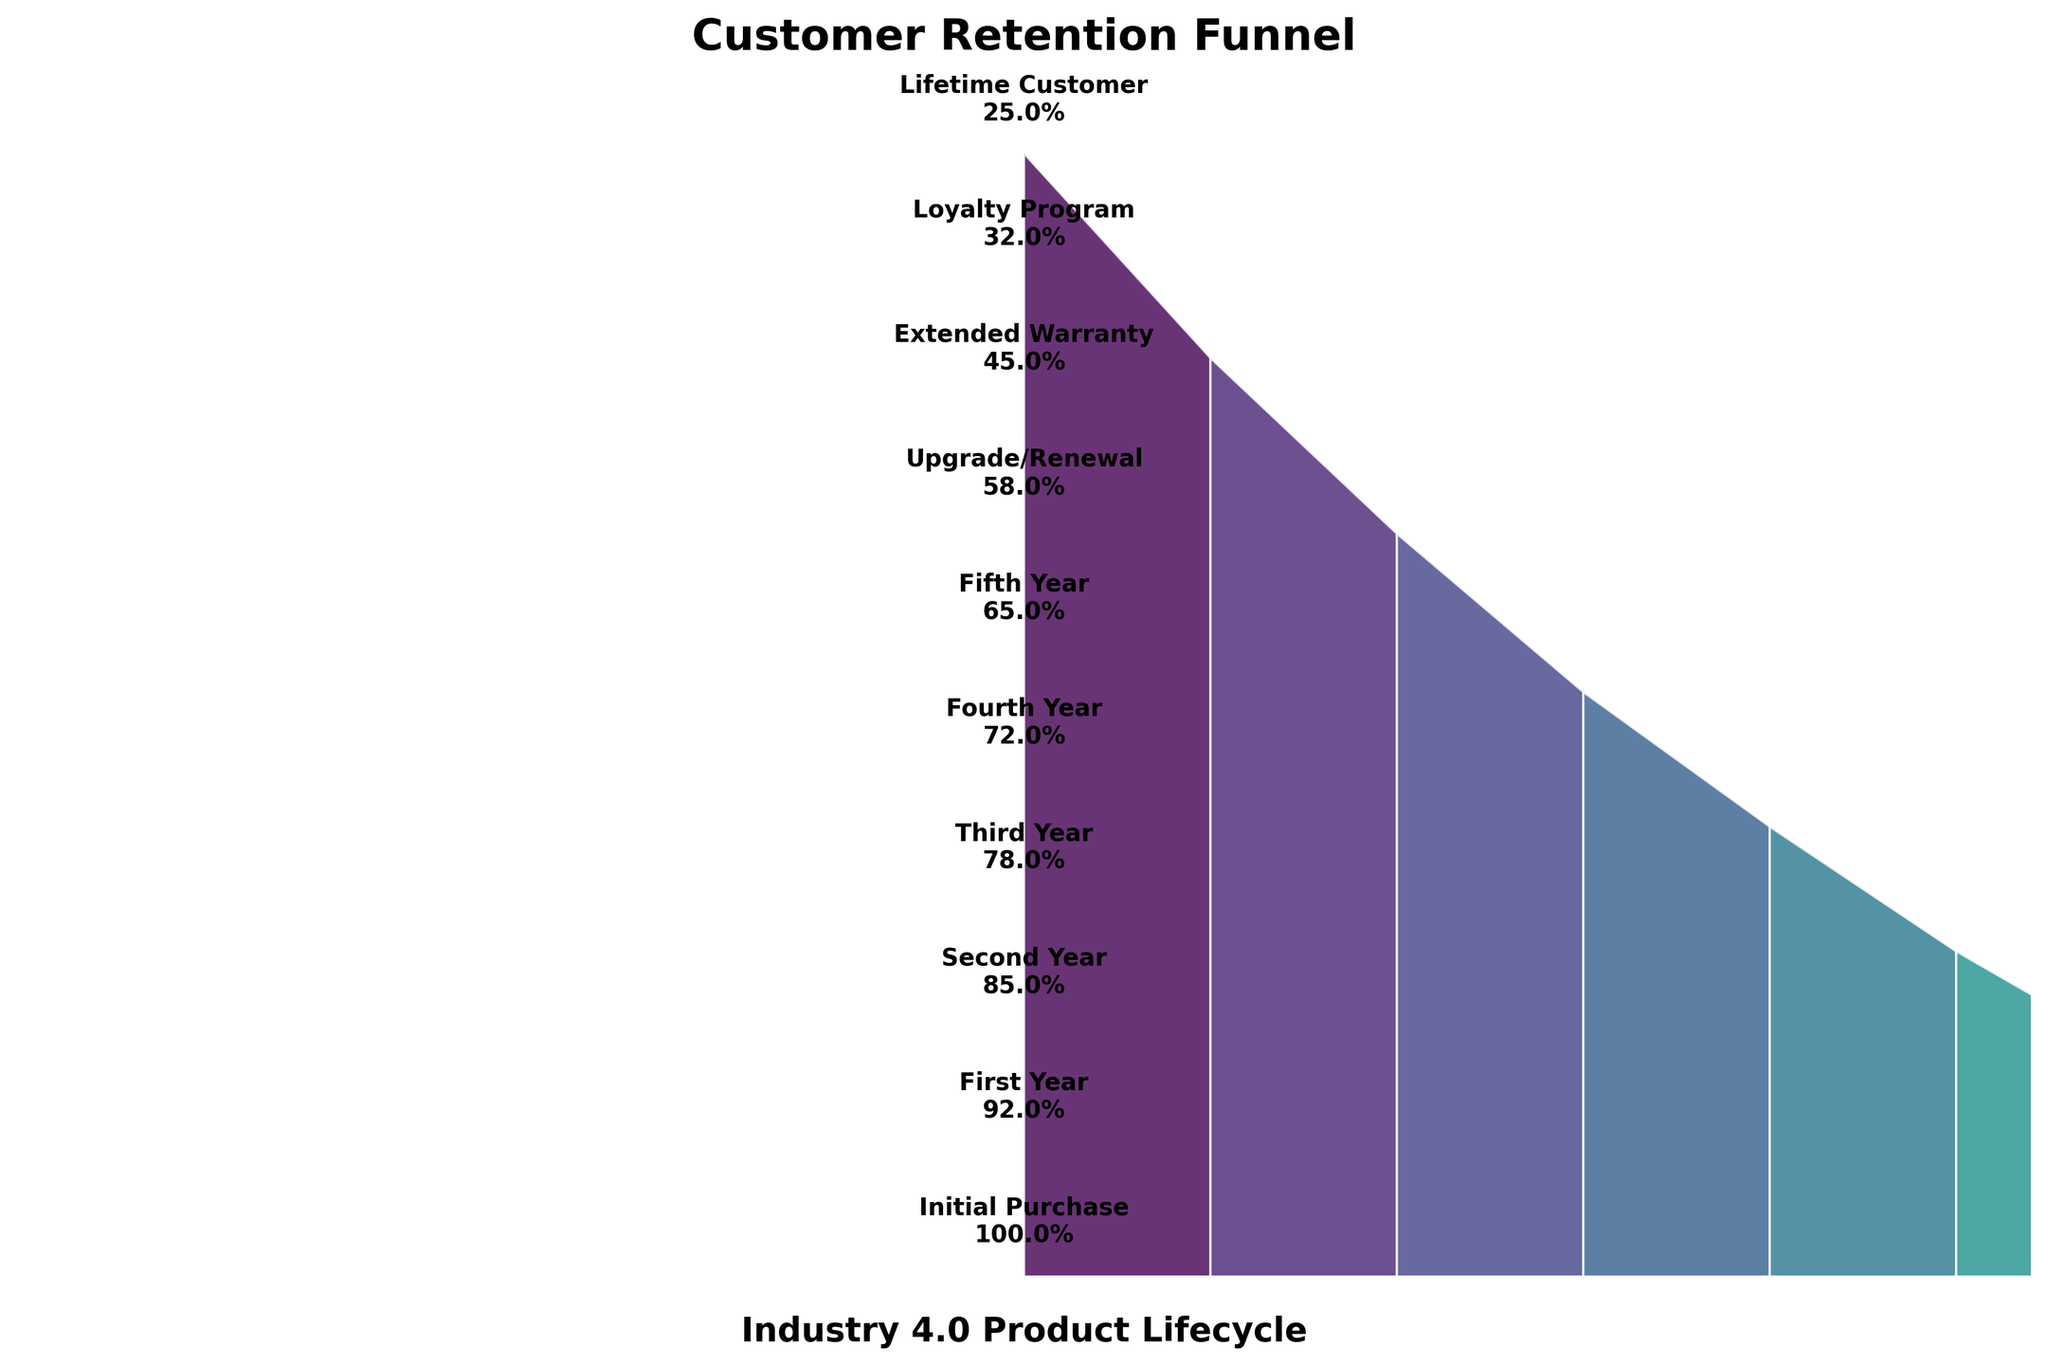What is the title of the figure? The title is positioned at the top of the figure and is clearly visible in bold font.
Answer: Customer Retention Funnel What is the retention rate at the "Third Year" stage? The retention rate at each stage is labeled on the figure. Look for the label corresponding to "Third Year."
Answer: 78% How many percentage points drop in retention is there between the "Initial Purchase" and the "Lifetime Customer" stages? Calculate the difference in retention rates between the "Initial Purchase" (100%) and the "Lifetime Customer" (25%).
Answer: 75% Which stage has the steepest drop in retention rate from the previous stage? Compare the difference in retention rates between consecutive stages to find the largest difference. The biggest drop is from "Loyalty Program" (32%) to "Lifetime Customer" (25%), which is a 7 percentage point drop.
Answer: Between Loyalty Program and Lifetime Customer What is the average retention rate across all stages? Sum the retention rates of all stages and divide by the number of stages. The sum is (100 + 92 + 85 + 78 + 72 + 65 + 58 + 45 + 32 + 25) = 652. Divide by the 10 stages gives the average retention rate.
Answer: 65.2% How does the retention rate at the "Fifth Year" stage compare to the "Second Year" stage? Check the retention rates for both stages and compare. The "Fifth Year" is at 65% while the "Second Year" is at 85%. The "Second Year" retention rate is higher.
Answer: Second Year is higher In which stages does the retention rate drop below 50%? Identify the stages where the retention rate is less than 50%. These are "Extended Warranty," "Loyalty Program," and "Lifetime Customer."
Answer: Extended Warranty, Loyalty Program, Lifetime Customer What is the retention rate difference between the "Upgrade/Renewal" and "Extended Warranty" stages? Calculate the difference in retention rates between these two stages. "Upgrade/Renewal" is 58% and "Extended Warranty" is 45%. The difference is 13 percentage points.
Answer: 13% Out of all the stages, which one has the lowest retention rate? Check all the stages for their retention rates and identify the one with the smallest value. The "Lifetime Customer" stage has the lowest retention rate.
Answer: Lifetime Customer 如何考虑将“初次购买”保持率解释为100%？ 100%的保持率通常意味着公司能够吸引所有初次体验产品的客户。Counts it as 100% due to the assumption that all first-time product buyers are retained initially.
Answer: 100%表示初次购买阶段没有客户流失 